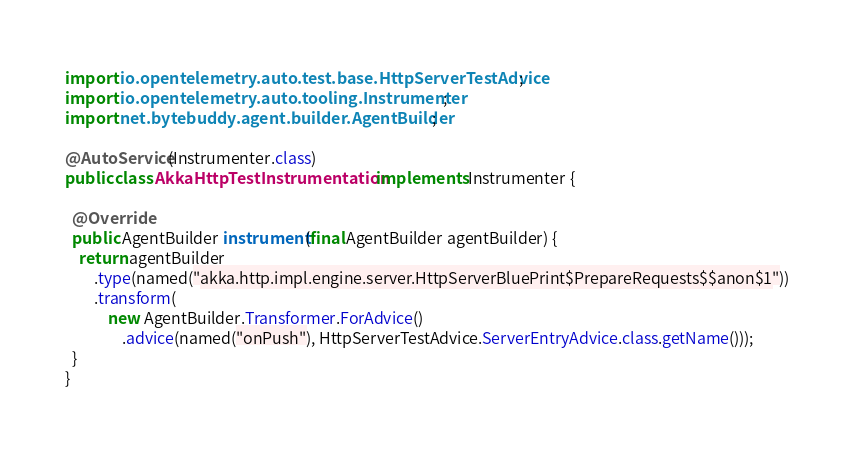Convert code to text. <code><loc_0><loc_0><loc_500><loc_500><_Java_>import io.opentelemetry.auto.test.base.HttpServerTestAdvice;
import io.opentelemetry.auto.tooling.Instrumenter;
import net.bytebuddy.agent.builder.AgentBuilder;

@AutoService(Instrumenter.class)
public class AkkaHttpTestInstrumentation implements Instrumenter {

  @Override
  public AgentBuilder instrument(final AgentBuilder agentBuilder) {
    return agentBuilder
        .type(named("akka.http.impl.engine.server.HttpServerBluePrint$PrepareRequests$$anon$1"))
        .transform(
            new AgentBuilder.Transformer.ForAdvice()
                .advice(named("onPush"), HttpServerTestAdvice.ServerEntryAdvice.class.getName()));
  }
}
</code> 